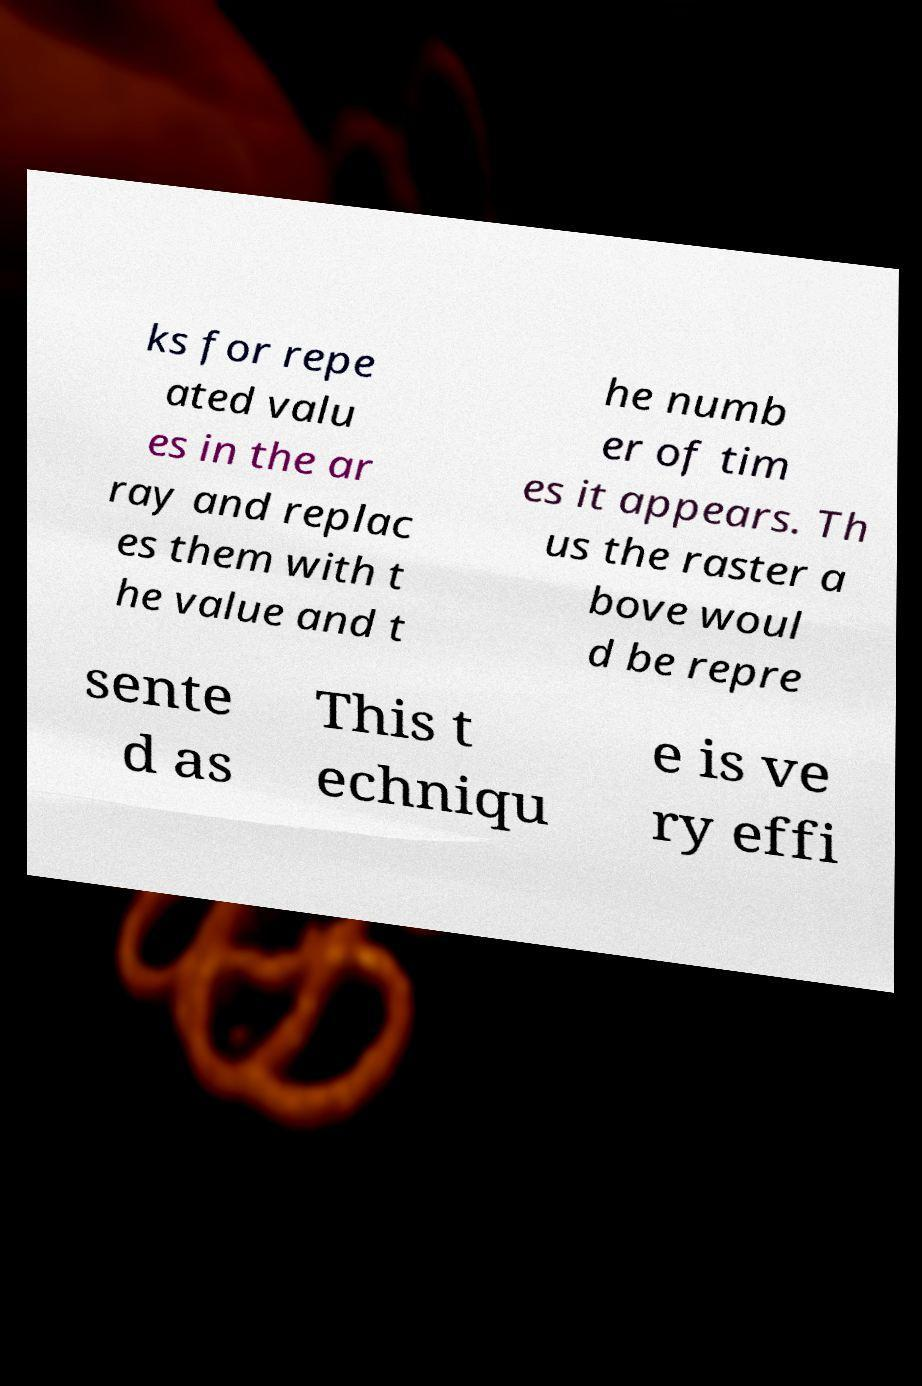Could you assist in decoding the text presented in this image and type it out clearly? ks for repe ated valu es in the ar ray and replac es them with t he value and t he numb er of tim es it appears. Th us the raster a bove woul d be repre sente d as This t echniqu e is ve ry effi 